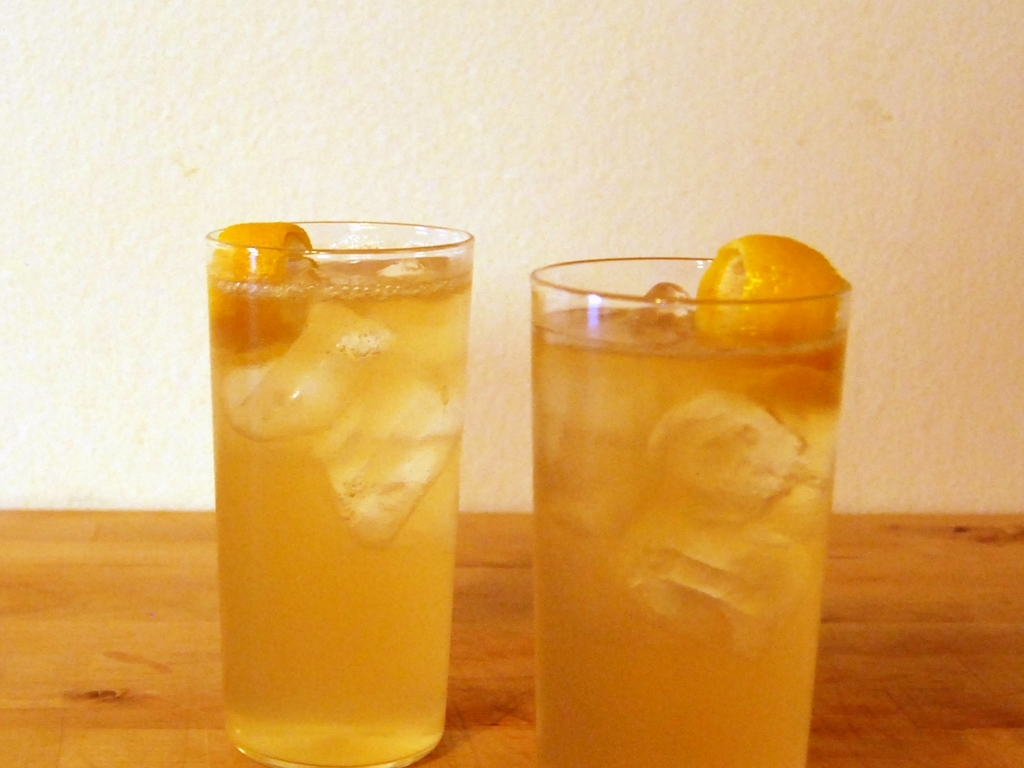Could you suggest a suitable setting or occasion for enjoying these drinks? Such refreshing iced tea drinks would be perfect for a laid-back backyard barbecue, a picnic in the park, or simply as a delightful accompaniment to a relaxing afternoon on the porch. Their casual yet classy presentation makes them versatile for various social gatherings or moments of personal leisure. 